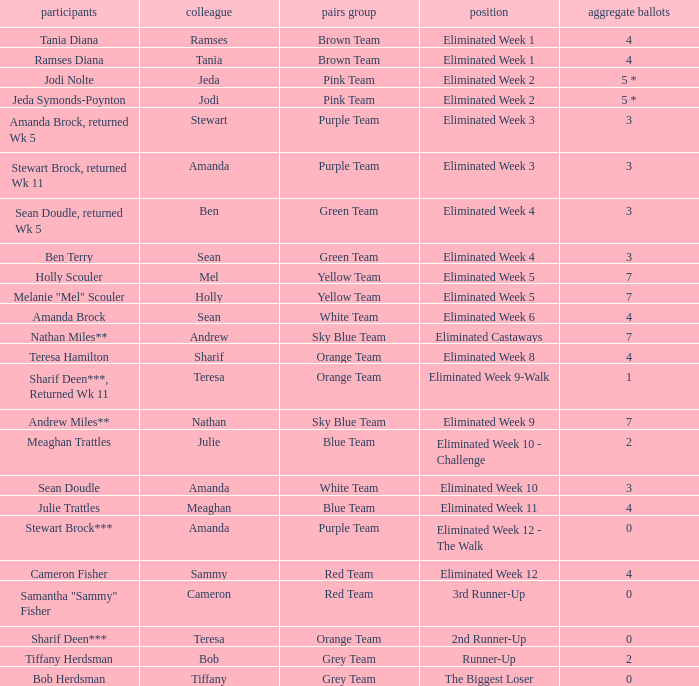What was Holly Scouler's total votes 7.0. 